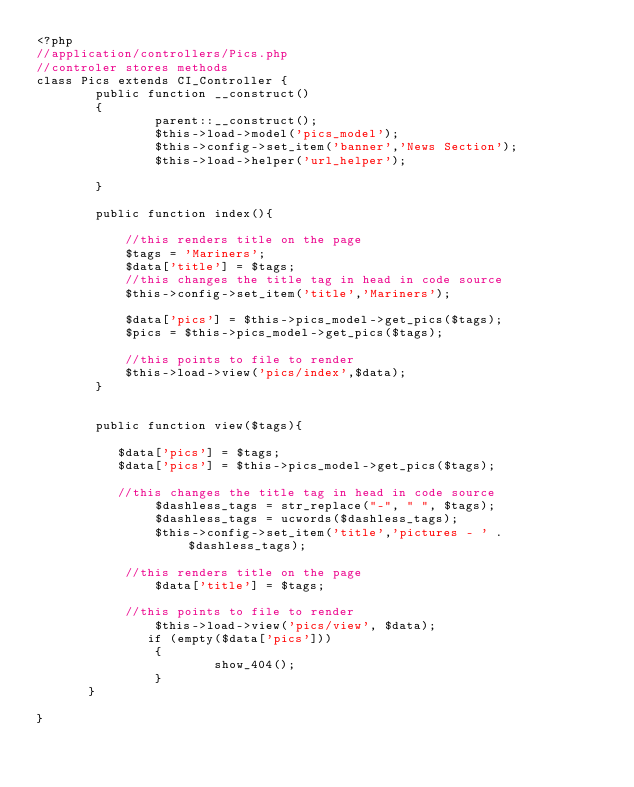Convert code to text. <code><loc_0><loc_0><loc_500><loc_500><_PHP_><?php
//application/controllers/Pics.php
//controler stores methods
class Pics extends CI_Controller {
        public function __construct()
        {
                parent::__construct();
                $this->load->model('pics_model');    
                $this->config->set_item('banner','News Section');
                $this->load->helper('url_helper');
              
        }
    
        public function index(){
            
            //this renders title on the page  
            $tags = 'Mariners';
            $data['title'] = $tags;
            //this changes the title tag in head in code source
            $this->config->set_item('title','Mariners');
           
            $data['pics'] = $this->pics_model->get_pics($tags);             
            $pics = $this->pics_model->get_pics($tags);
            
            //this points to file to render   
            $this->load->view('pics/index',$data);
        }
      
    
        public function view($tags){
           
           $data['pics'] = $tags;
           $data['pics'] = $this->pics_model->get_pics($tags); 
            
           //this changes the title tag in head in code source
                $dashless_tags = str_replace("-", " ", $tags);
                $dashless_tags = ucwords($dashless_tags);
                $this->config->set_item('title','pictures - ' . $dashless_tags);
              
            //this renders title on the page    
                $data['title'] = $tags;
        
            //this points to file to render    
                $this->load->view('pics/view', $data);
               if (empty($data['pics']))
                {
                        show_404();
                }
       }
            
}</code> 